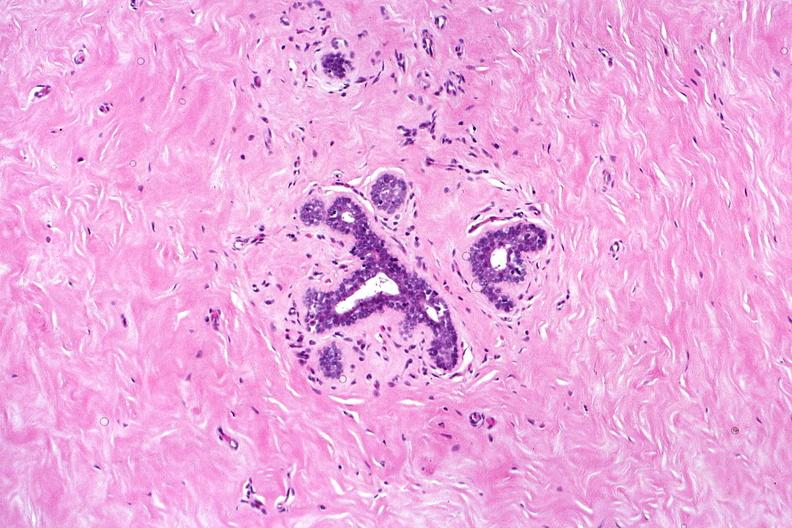does this image show normal breast?
Answer the question using a single word or phrase. Yes 